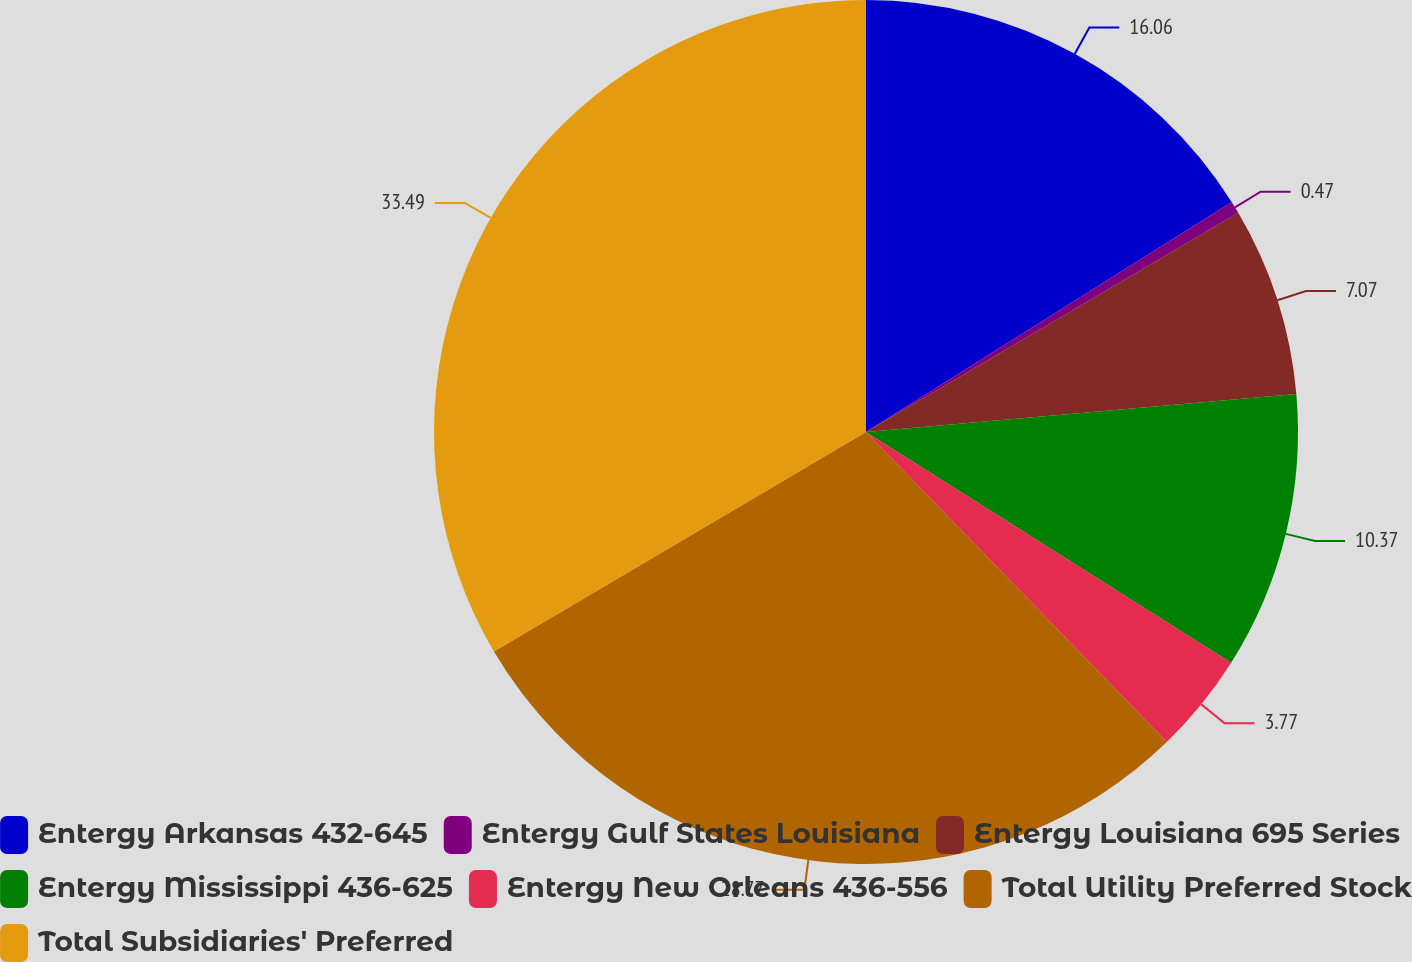Convert chart to OTSL. <chart><loc_0><loc_0><loc_500><loc_500><pie_chart><fcel>Entergy Arkansas 432-645<fcel>Entergy Gulf States Louisiana<fcel>Entergy Louisiana 695 Series<fcel>Entergy Mississippi 436-625<fcel>Entergy New Orleans 436-556<fcel>Total Utility Preferred Stock<fcel>Total Subsidiaries' Preferred<nl><fcel>16.06%<fcel>0.47%<fcel>7.07%<fcel>10.37%<fcel>3.77%<fcel>28.77%<fcel>33.48%<nl></chart> 